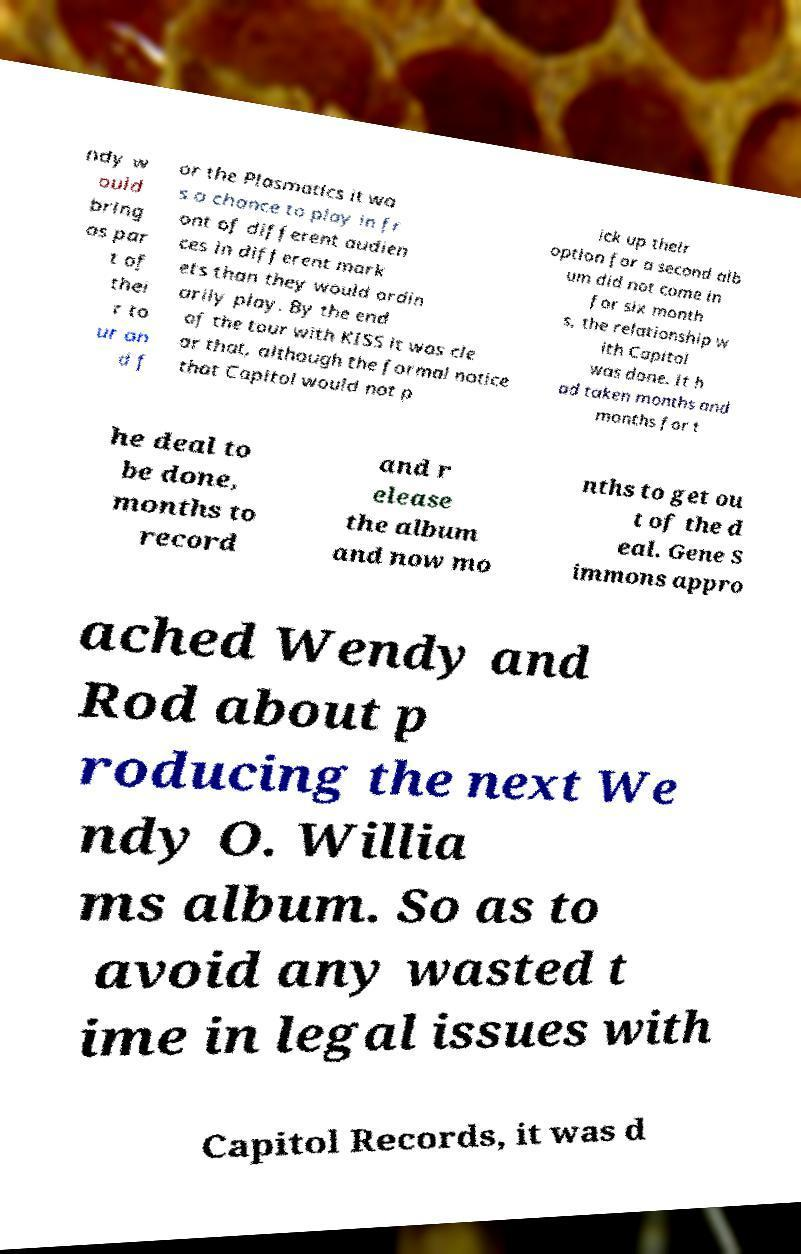I need the written content from this picture converted into text. Can you do that? ndy w ould bring as par t of thei r to ur an d f or the Plasmatics it wa s a chance to play in fr ont of different audien ces in different mark ets than they would ordin arily play. By the end of the tour with KISS it was cle ar that, although the formal notice that Capitol would not p ick up their option for a second alb um did not come in for six month s, the relationship w ith Capitol was done. It h ad taken months and months for t he deal to be done, months to record and r elease the album and now mo nths to get ou t of the d eal. Gene S immons appro ached Wendy and Rod about p roducing the next We ndy O. Willia ms album. So as to avoid any wasted t ime in legal issues with Capitol Records, it was d 